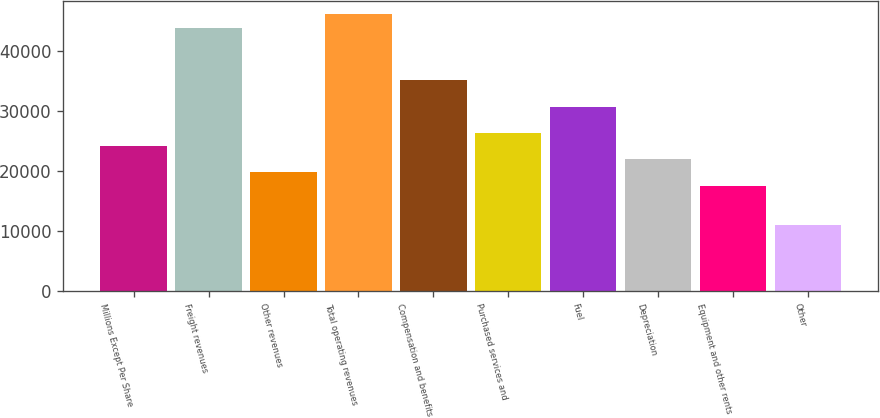Convert chart. <chart><loc_0><loc_0><loc_500><loc_500><bar_chart><fcel>Millions Except Per Share<fcel>Freight revenues<fcel>Other revenues<fcel>Total operating revenues<fcel>Compensation and benefits<fcel>Purchased services and<fcel>Fuel<fcel>Depreciation<fcel>Equipment and other rents<fcel>Other<nl><fcel>24159.1<fcel>43924.5<fcel>19766.8<fcel>46120.6<fcel>35139.9<fcel>26355.3<fcel>30747.6<fcel>21963<fcel>17570.7<fcel>10982.2<nl></chart> 